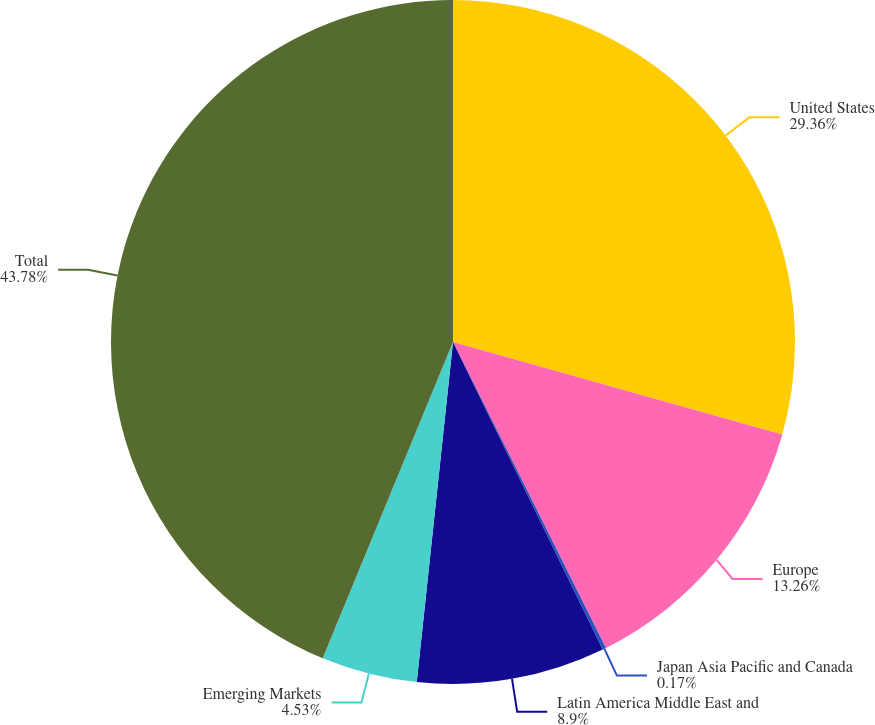Convert chart to OTSL. <chart><loc_0><loc_0><loc_500><loc_500><pie_chart><fcel>United States<fcel>Europe<fcel>Japan Asia Pacific and Canada<fcel>Latin America Middle East and<fcel>Emerging Markets<fcel>Total<nl><fcel>29.36%<fcel>13.26%<fcel>0.17%<fcel>8.9%<fcel>4.53%<fcel>43.78%<nl></chart> 